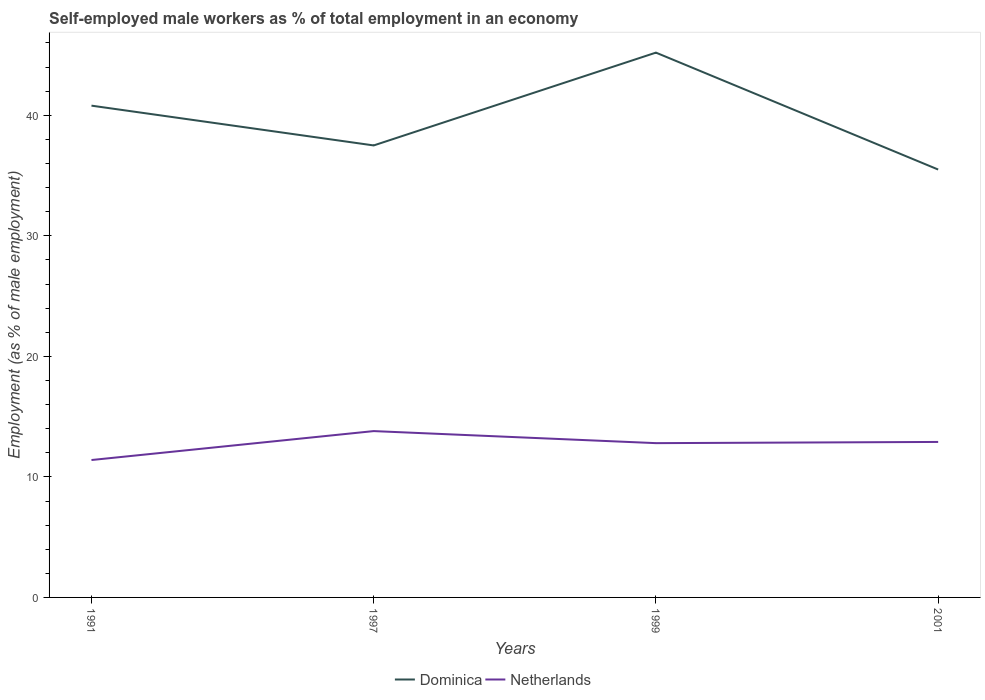How many different coloured lines are there?
Ensure brevity in your answer.  2. Does the line corresponding to Dominica intersect with the line corresponding to Netherlands?
Provide a succinct answer. No. Is the number of lines equal to the number of legend labels?
Offer a terse response. Yes. Across all years, what is the maximum percentage of self-employed male workers in Dominica?
Ensure brevity in your answer.  35.5. In which year was the percentage of self-employed male workers in Netherlands maximum?
Provide a short and direct response. 1991. What is the total percentage of self-employed male workers in Netherlands in the graph?
Your response must be concise. -2.4. What is the difference between the highest and the second highest percentage of self-employed male workers in Dominica?
Offer a terse response. 9.7. What is the difference between the highest and the lowest percentage of self-employed male workers in Netherlands?
Provide a short and direct response. 3. Is the percentage of self-employed male workers in Dominica strictly greater than the percentage of self-employed male workers in Netherlands over the years?
Your answer should be very brief. No. How many years are there in the graph?
Your answer should be very brief. 4. Does the graph contain any zero values?
Offer a very short reply. No. Does the graph contain grids?
Offer a very short reply. No. What is the title of the graph?
Provide a succinct answer. Self-employed male workers as % of total employment in an economy. Does "Peru" appear as one of the legend labels in the graph?
Ensure brevity in your answer.  No. What is the label or title of the X-axis?
Your answer should be compact. Years. What is the label or title of the Y-axis?
Make the answer very short. Employment (as % of male employment). What is the Employment (as % of male employment) of Dominica in 1991?
Your answer should be very brief. 40.8. What is the Employment (as % of male employment) of Netherlands in 1991?
Your answer should be very brief. 11.4. What is the Employment (as % of male employment) in Dominica in 1997?
Your answer should be very brief. 37.5. What is the Employment (as % of male employment) in Netherlands in 1997?
Provide a succinct answer. 13.8. What is the Employment (as % of male employment) of Dominica in 1999?
Your answer should be very brief. 45.2. What is the Employment (as % of male employment) in Netherlands in 1999?
Your answer should be very brief. 12.8. What is the Employment (as % of male employment) in Dominica in 2001?
Your response must be concise. 35.5. What is the Employment (as % of male employment) of Netherlands in 2001?
Give a very brief answer. 12.9. Across all years, what is the maximum Employment (as % of male employment) in Dominica?
Your answer should be compact. 45.2. Across all years, what is the maximum Employment (as % of male employment) in Netherlands?
Your answer should be very brief. 13.8. Across all years, what is the minimum Employment (as % of male employment) of Dominica?
Your answer should be very brief. 35.5. Across all years, what is the minimum Employment (as % of male employment) in Netherlands?
Provide a short and direct response. 11.4. What is the total Employment (as % of male employment) of Dominica in the graph?
Provide a short and direct response. 159. What is the total Employment (as % of male employment) of Netherlands in the graph?
Ensure brevity in your answer.  50.9. What is the difference between the Employment (as % of male employment) of Netherlands in 1991 and that in 1997?
Offer a terse response. -2.4. What is the difference between the Employment (as % of male employment) of Dominica in 1991 and that in 1999?
Provide a succinct answer. -4.4. What is the difference between the Employment (as % of male employment) of Netherlands in 1991 and that in 1999?
Make the answer very short. -1.4. What is the difference between the Employment (as % of male employment) in Dominica in 1991 and that in 2001?
Your answer should be very brief. 5.3. What is the difference between the Employment (as % of male employment) of Dominica in 1997 and that in 1999?
Ensure brevity in your answer.  -7.7. What is the difference between the Employment (as % of male employment) of Netherlands in 1997 and that in 1999?
Provide a succinct answer. 1. What is the difference between the Employment (as % of male employment) of Dominica in 1997 and that in 2001?
Give a very brief answer. 2. What is the difference between the Employment (as % of male employment) in Netherlands in 1997 and that in 2001?
Your response must be concise. 0.9. What is the difference between the Employment (as % of male employment) in Dominica in 1999 and that in 2001?
Give a very brief answer. 9.7. What is the difference between the Employment (as % of male employment) in Dominica in 1991 and the Employment (as % of male employment) in Netherlands in 1997?
Give a very brief answer. 27. What is the difference between the Employment (as % of male employment) in Dominica in 1991 and the Employment (as % of male employment) in Netherlands in 2001?
Your answer should be compact. 27.9. What is the difference between the Employment (as % of male employment) in Dominica in 1997 and the Employment (as % of male employment) in Netherlands in 1999?
Offer a very short reply. 24.7. What is the difference between the Employment (as % of male employment) of Dominica in 1997 and the Employment (as % of male employment) of Netherlands in 2001?
Make the answer very short. 24.6. What is the difference between the Employment (as % of male employment) in Dominica in 1999 and the Employment (as % of male employment) in Netherlands in 2001?
Ensure brevity in your answer.  32.3. What is the average Employment (as % of male employment) in Dominica per year?
Your answer should be compact. 39.75. What is the average Employment (as % of male employment) of Netherlands per year?
Keep it short and to the point. 12.72. In the year 1991, what is the difference between the Employment (as % of male employment) of Dominica and Employment (as % of male employment) of Netherlands?
Keep it short and to the point. 29.4. In the year 1997, what is the difference between the Employment (as % of male employment) of Dominica and Employment (as % of male employment) of Netherlands?
Make the answer very short. 23.7. In the year 1999, what is the difference between the Employment (as % of male employment) of Dominica and Employment (as % of male employment) of Netherlands?
Make the answer very short. 32.4. In the year 2001, what is the difference between the Employment (as % of male employment) of Dominica and Employment (as % of male employment) of Netherlands?
Offer a very short reply. 22.6. What is the ratio of the Employment (as % of male employment) of Dominica in 1991 to that in 1997?
Your answer should be compact. 1.09. What is the ratio of the Employment (as % of male employment) in Netherlands in 1991 to that in 1997?
Give a very brief answer. 0.83. What is the ratio of the Employment (as % of male employment) in Dominica in 1991 to that in 1999?
Ensure brevity in your answer.  0.9. What is the ratio of the Employment (as % of male employment) of Netherlands in 1991 to that in 1999?
Make the answer very short. 0.89. What is the ratio of the Employment (as % of male employment) of Dominica in 1991 to that in 2001?
Your response must be concise. 1.15. What is the ratio of the Employment (as % of male employment) of Netherlands in 1991 to that in 2001?
Make the answer very short. 0.88. What is the ratio of the Employment (as % of male employment) of Dominica in 1997 to that in 1999?
Ensure brevity in your answer.  0.83. What is the ratio of the Employment (as % of male employment) in Netherlands in 1997 to that in 1999?
Your answer should be very brief. 1.08. What is the ratio of the Employment (as % of male employment) of Dominica in 1997 to that in 2001?
Your response must be concise. 1.06. What is the ratio of the Employment (as % of male employment) of Netherlands in 1997 to that in 2001?
Your response must be concise. 1.07. What is the ratio of the Employment (as % of male employment) in Dominica in 1999 to that in 2001?
Offer a very short reply. 1.27. What is the ratio of the Employment (as % of male employment) of Netherlands in 1999 to that in 2001?
Your answer should be compact. 0.99. What is the difference between the highest and the lowest Employment (as % of male employment) of Dominica?
Provide a succinct answer. 9.7. What is the difference between the highest and the lowest Employment (as % of male employment) in Netherlands?
Offer a very short reply. 2.4. 